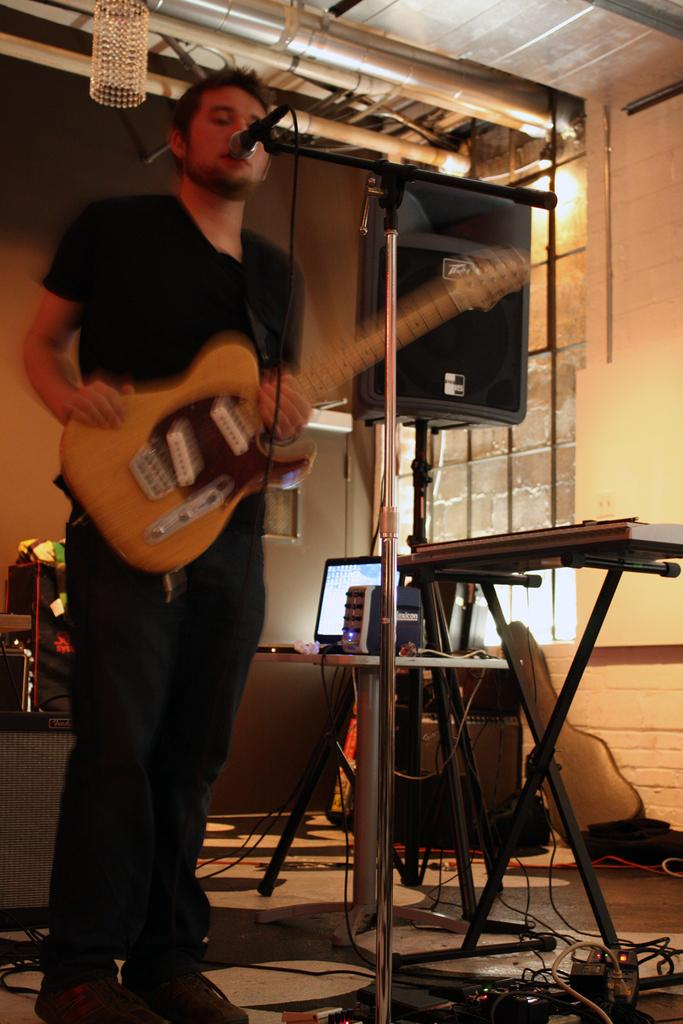What is the main subject of the image? The main subject of the image is a man. What is the man doing in the image? The man is standing and singing in the image. What object is the man holding in his hand? The man is holding a guitar in his hand. What device is in front of the man? There is a microphone in front of the man. How many trucks are visible in the image? There are no trucks visible in the image; it features a man holding a guitar and singing with a microphone in front of him. What type of fang can be seen in the image? There is no fang present in the image. 